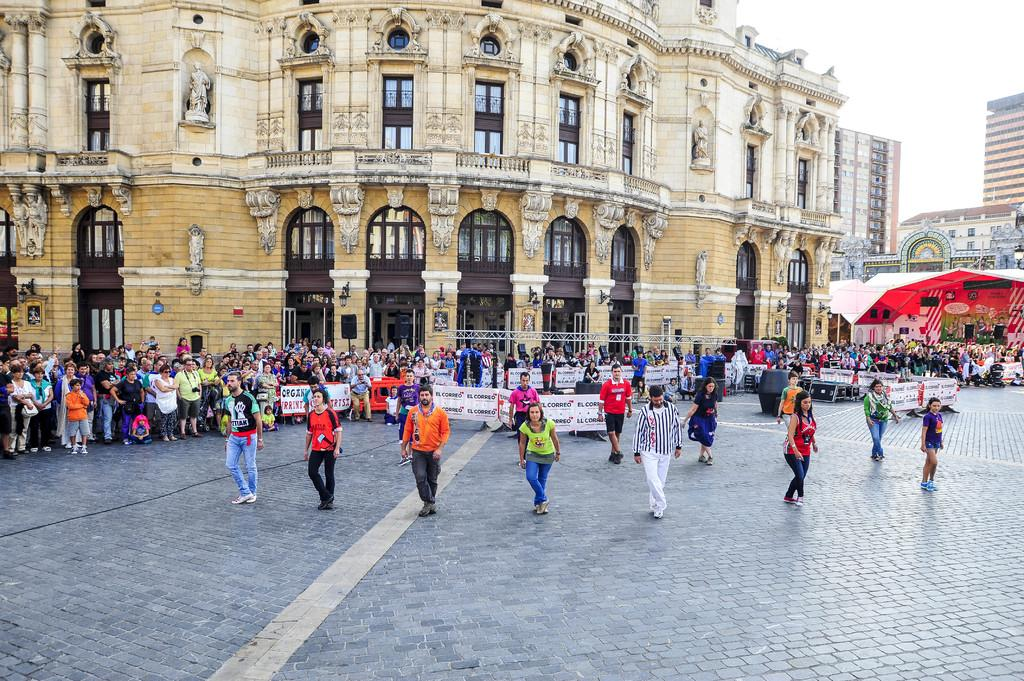What is happening in the image involving the people? Some people are dancing in the image. What structure can be seen in the image? There is a truss in the image. What type of shelter is present in the image? There is a tent in the image. What type of signage is visible in the image? There are banners in the image. What type of man-made structures are visible in the image? There are buildings in the image. What type of objects are present in the image? There are objects in the image. What can be seen in the background of the image? The sky is visible in the background of the image. What type of detail is visible on the vest of the person in the image? There is no vest present in the image, so it is not possible to answer that question. What type of cream is being used by the people in the image? There is no cream present in the image, and no indication that any cream is being used. 